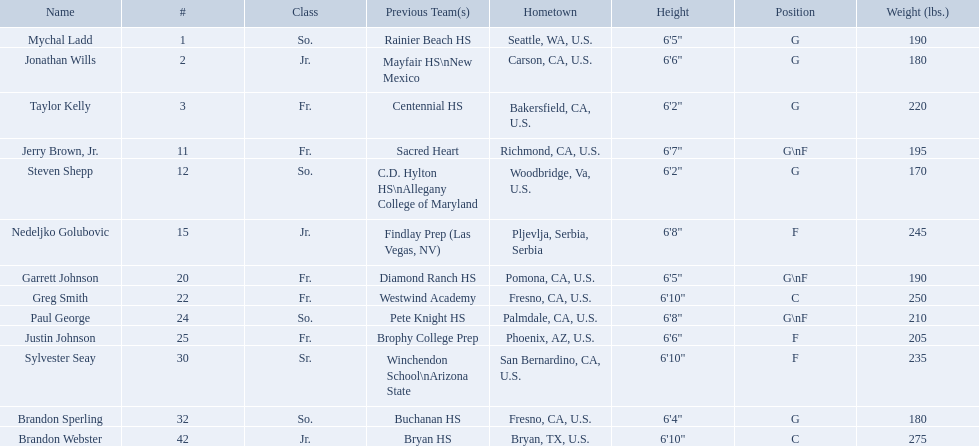Who are all the players in the 2009-10 fresno state bulldogs men's basketball team? Mychal Ladd, Jonathan Wills, Taylor Kelly, Jerry Brown, Jr., Steven Shepp, Nedeljko Golubovic, Garrett Johnson, Greg Smith, Paul George, Justin Johnson, Sylvester Seay, Brandon Sperling, Brandon Webster. Of these players, who are the ones who play forward? Jerry Brown, Jr., Nedeljko Golubovic, Garrett Johnson, Paul George, Justin Johnson, Sylvester Seay. Of these players, which ones only play forward and no other position? Nedeljko Golubovic, Justin Johnson, Sylvester Seay. Of these players, who is the shortest? Justin Johnson. What are the names for all players? Mychal Ladd, Jonathan Wills, Taylor Kelly, Jerry Brown, Jr., Steven Shepp, Nedeljko Golubovic, Garrett Johnson, Greg Smith, Paul George, Justin Johnson, Sylvester Seay, Brandon Sperling, Brandon Webster. Which players are taller than 6'8? Nedeljko Golubovic, Greg Smith, Paul George, Sylvester Seay, Brandon Webster. How tall is paul george? 6'8". How tall is greg smith? 6'10". Of these two, which it tallest? Greg Smith. 